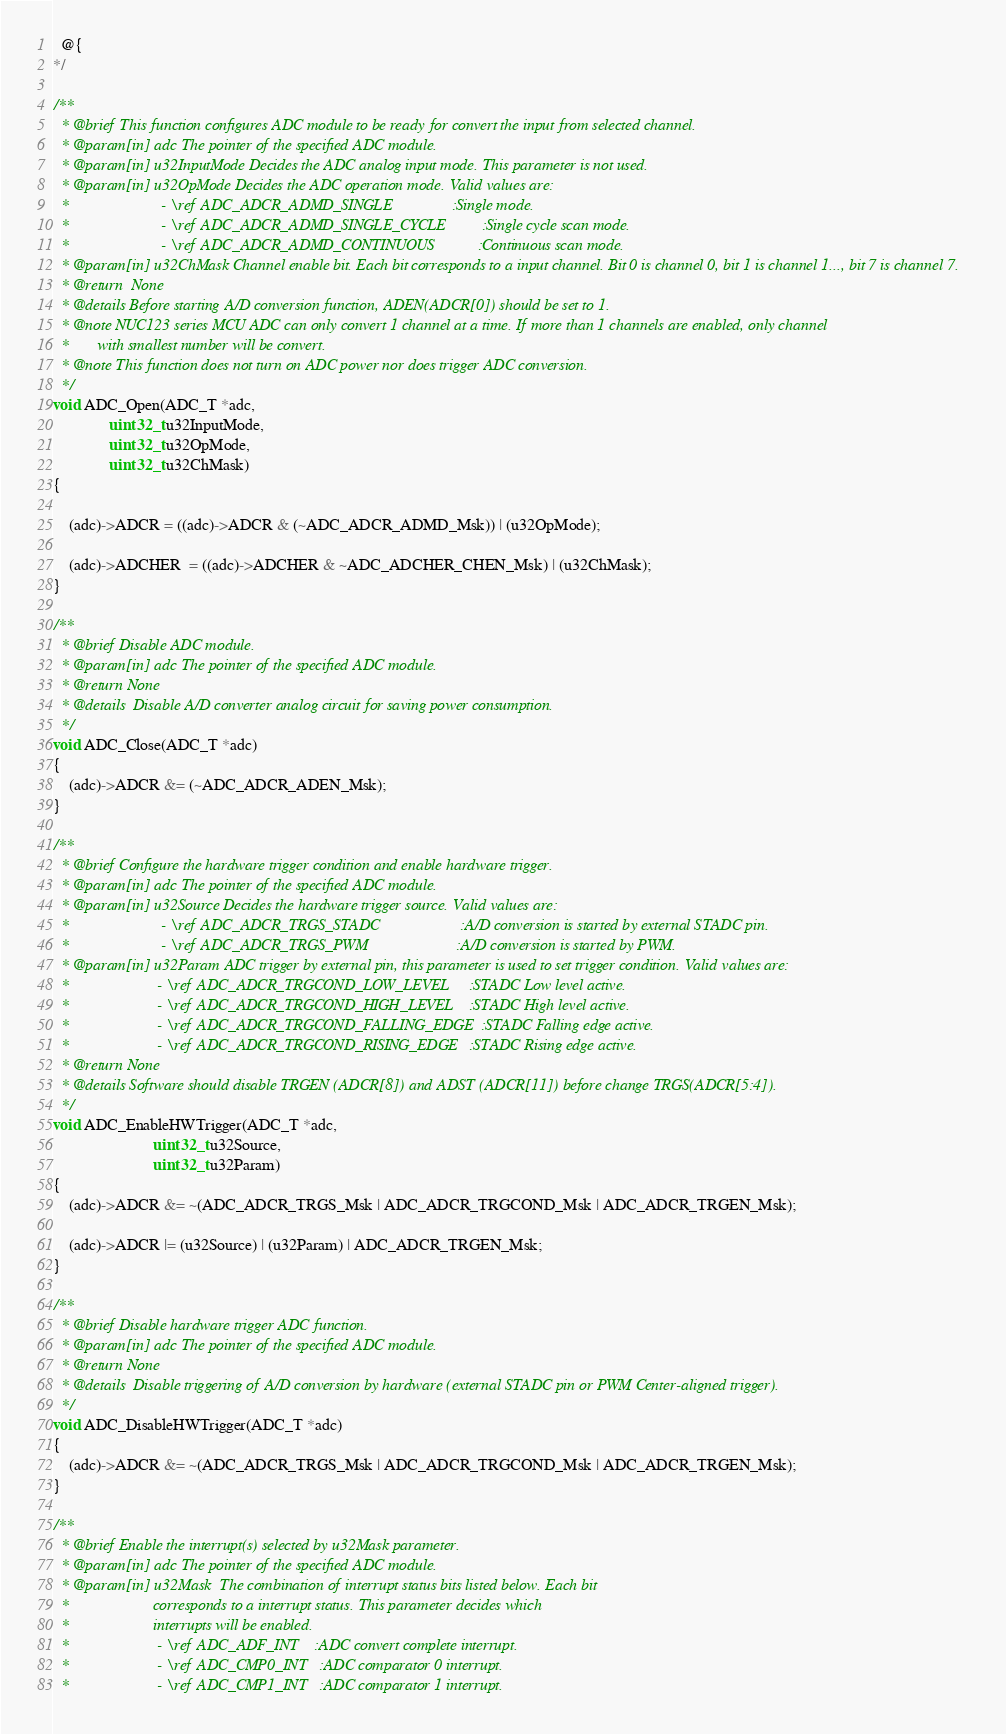Convert code to text. <code><loc_0><loc_0><loc_500><loc_500><_C_>  @{
*/

/**
  * @brief This function configures ADC module to be ready for convert the input from selected channel.
  * @param[in] adc The pointer of the specified ADC module.
  * @param[in] u32InputMode Decides the ADC analog input mode. This parameter is not used.
  * @param[in] u32OpMode Decides the ADC operation mode. Valid values are:
  *                       - \ref ADC_ADCR_ADMD_SINGLE               :Single mode.
  *                       - \ref ADC_ADCR_ADMD_SINGLE_CYCLE         :Single cycle scan mode.
  *                       - \ref ADC_ADCR_ADMD_CONTINUOUS           :Continuous scan mode.
  * @param[in] u32ChMask Channel enable bit. Each bit corresponds to a input channel. Bit 0 is channel 0, bit 1 is channel 1..., bit 7 is channel 7.
  * @return  None
  * @details Before starting A/D conversion function, ADEN(ADCR[0]) should be set to 1.
  * @note NUC123 series MCU ADC can only convert 1 channel at a time. If more than 1 channels are enabled, only channel
  *       with smallest number will be convert.
  * @note This function does not turn on ADC power nor does trigger ADC conversion.
  */
void ADC_Open(ADC_T *adc,
              uint32_t u32InputMode,
              uint32_t u32OpMode,
              uint32_t u32ChMask)
{

    (adc)->ADCR = ((adc)->ADCR & (~ADC_ADCR_ADMD_Msk)) | (u32OpMode);

    (adc)->ADCHER  = ((adc)->ADCHER & ~ADC_ADCHER_CHEN_Msk) | (u32ChMask);
}

/**
  * @brief Disable ADC module.
  * @param[in] adc The pointer of the specified ADC module.
  * @return None
  * @details  Disable A/D converter analog circuit for saving power consumption.
  */
void ADC_Close(ADC_T *adc)
{
    (adc)->ADCR &= (~ADC_ADCR_ADEN_Msk);
}

/**
  * @brief Configure the hardware trigger condition and enable hardware trigger.
  * @param[in] adc The pointer of the specified ADC module.
  * @param[in] u32Source Decides the hardware trigger source. Valid values are:
  *                       - \ref ADC_ADCR_TRGS_STADC                    :A/D conversion is started by external STADC pin.
  *                       - \ref ADC_ADCR_TRGS_PWM                      :A/D conversion is started by PWM.
  * @param[in] u32Param ADC trigger by external pin, this parameter is used to set trigger condition. Valid values are:
  *                      - \ref ADC_ADCR_TRGCOND_LOW_LEVEL     :STADC Low level active.
  *                      - \ref ADC_ADCR_TRGCOND_HIGH_LEVEL    :STADC High level active.
  *                      - \ref ADC_ADCR_TRGCOND_FALLING_EDGE  :STADC Falling edge active.
  *                      - \ref ADC_ADCR_TRGCOND_RISING_EDGE   :STADC Rising edge active.
  * @return None
  * @details Software should disable TRGEN (ADCR[8]) and ADST (ADCR[11]) before change TRGS(ADCR[5:4]).
  */
void ADC_EnableHWTrigger(ADC_T *adc,
                         uint32_t u32Source,
                         uint32_t u32Param)
{
    (adc)->ADCR &= ~(ADC_ADCR_TRGS_Msk | ADC_ADCR_TRGCOND_Msk | ADC_ADCR_TRGEN_Msk);

    (adc)->ADCR |= (u32Source) | (u32Param) | ADC_ADCR_TRGEN_Msk;
}

/**
  * @brief Disable hardware trigger ADC function.
  * @param[in] adc The pointer of the specified ADC module.
  * @return None
  * @details  Disable triggering of A/D conversion by hardware (external STADC pin or PWM Center-aligned trigger).
  */
void ADC_DisableHWTrigger(ADC_T *adc)
{
    (adc)->ADCR &= ~(ADC_ADCR_TRGS_Msk | ADC_ADCR_TRGCOND_Msk | ADC_ADCR_TRGEN_Msk);
}

/**
  * @brief Enable the interrupt(s) selected by u32Mask parameter.
  * @param[in] adc The pointer of the specified ADC module.
  * @param[in] u32Mask  The combination of interrupt status bits listed below. Each bit
  *                     corresponds to a interrupt status. This parameter decides which
  *                     interrupts will be enabled.
  *                      - \ref ADC_ADF_INT    :ADC convert complete interrupt.
  *                      - \ref ADC_CMP0_INT   :ADC comparator 0 interrupt.
  *                      - \ref ADC_CMP1_INT   :ADC comparator 1 interrupt.</code> 